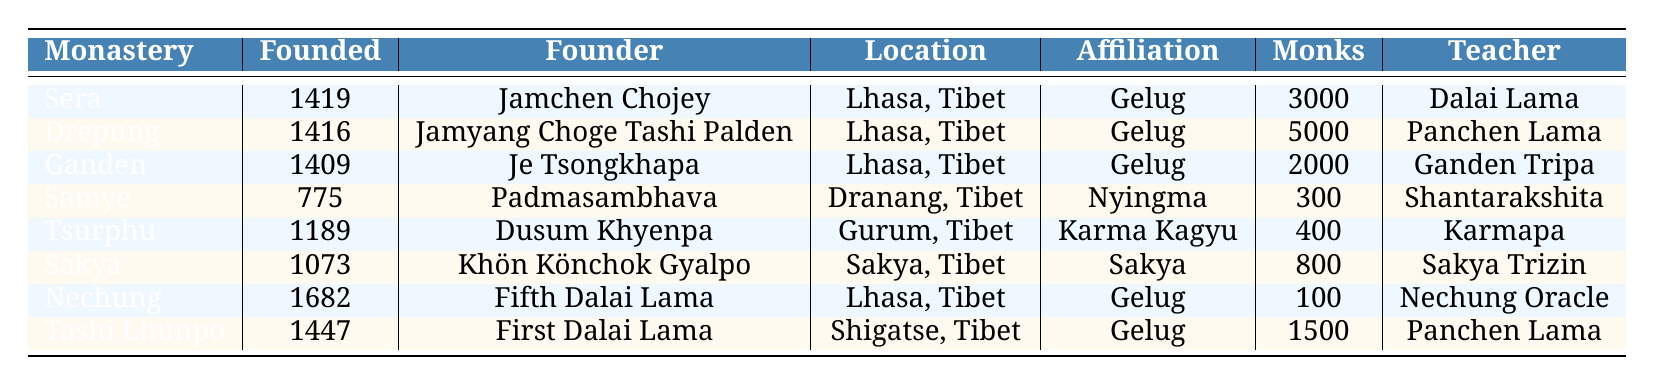What is the founding date of Samye Monastery? The table has a row for Samye Monastery, and it indicates that the founding date is listed as 775.
Answer: 775 Which monastery has the highest number of monks? By looking at the "NumberOfMonks" column, Drepung Monastery has the highest number of monks at 5000.
Answer: Drepung Monastery What affiliation does Tsurphu Monastery belong to? Checking the "CurrentAffiliation" column corresponds to Tsurphu Monastery, the affiliation listed is Karma Kagyu.
Answer: Karma Kagyu Is Sakya Monastery affiliated with Gelug? The "CurrentAffiliation" column shows that Sakya Monastery is affiliated with Sakya, not Gelug.
Answer: No Calculate the total number of monks in all monasteries listed. To find the total number of monks, we sum each value: 3000 (Sera) + 5000 (Drepung) + 2000 (Ganden) + 300 (Samye) + 400 (Tsurphu) + 800 (Sakya) + 100 (Nechung) + 1500 (Tashi Lhunpo) = 12,600.
Answer: 12600 What is the average founding year of the monasteries? The founding years are: 1419, 1416, 1409, 775, 1189, 1073, 1682, 1447. Summing them gives 12,570 and dividing by 8 (the number of monasteries) results in an average of approximately 1571.25, rounding gives us 1571.
Answer: 1571 Which monastery was founded first? Inspecting the founding years, Sakya Monastery established in 1073 has the earliest date compared to the others listed.
Answer: Sakya Monastery How many monasteries are affiliated with Gelug? The table displays four monasteries (Sera, Drepung, Ganden, Nechung, Tashi Lhunpo) affiliated with Gelug, which can be counted from the "CurrentAffiliation" column.
Answer: Four monasteries Who was the founder of Tashi Lhunpo Monastery? Referring to the "Founder" column for Tashi Lhunpo Monastery indicates it was founded by the First Dalai Lama.
Answer: First Dalai Lama Is there any monastery founded by Padmasambhava? Looking at the "Founder" column, it shows that Samye Monastery was indeed founded by Padmasambhava.
Answer: Yes What is the difference in the number of monks between Sakya and Sera Monastories? Sera Monastery has 3000 monks and Sakya Monastery has 800. Subtracting 800 from 3000 gives us a difference of 2200.
Answer: 2200 